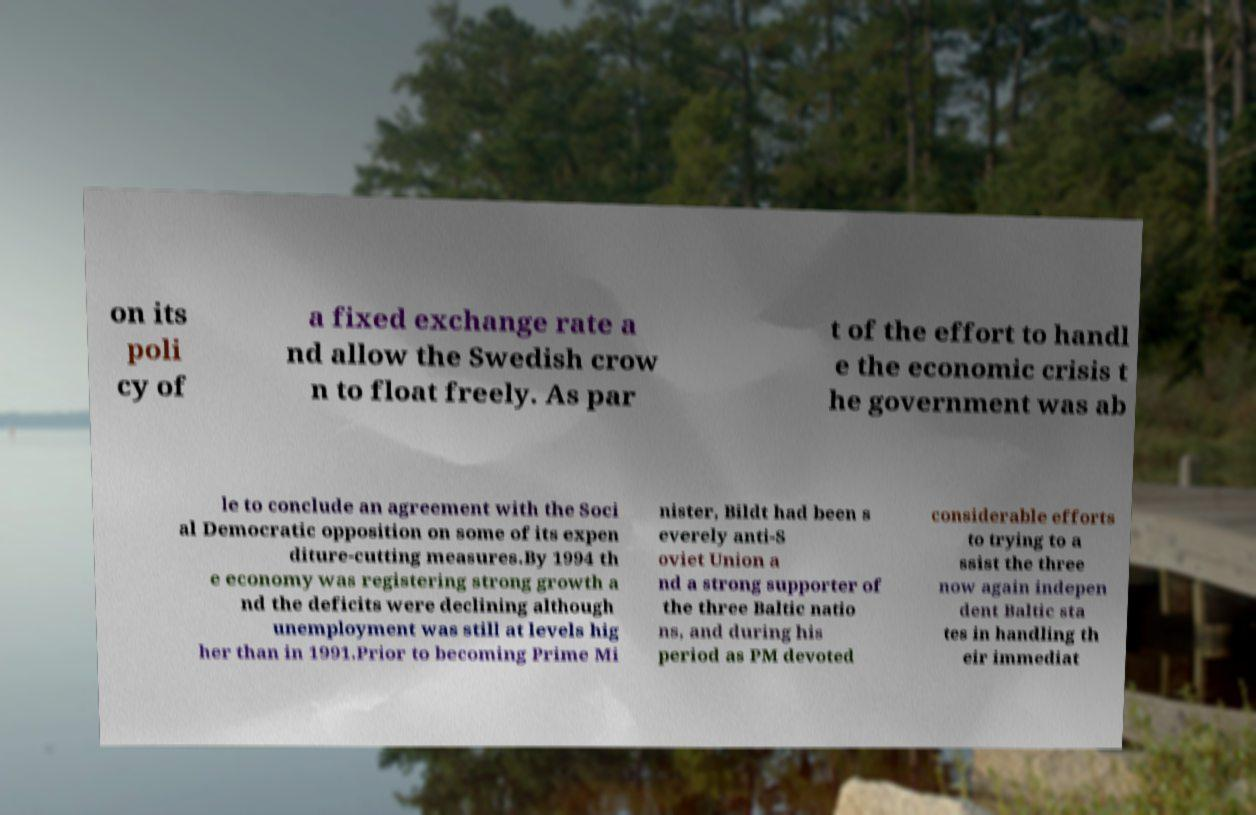Please read and relay the text visible in this image. What does it say? on its poli cy of a fixed exchange rate a nd allow the Swedish crow n to float freely. As par t of the effort to handl e the economic crisis t he government was ab le to conclude an agreement with the Soci al Democratic opposition on some of its expen diture-cutting measures.By 1994 th e economy was registering strong growth a nd the deficits were declining although unemployment was still at levels hig her than in 1991.Prior to becoming Prime Mi nister, Bildt had been s everely anti-S oviet Union a nd a strong supporter of the three Baltic natio ns, and during his period as PM devoted considerable efforts to trying to a ssist the three now again indepen dent Baltic sta tes in handling th eir immediat 